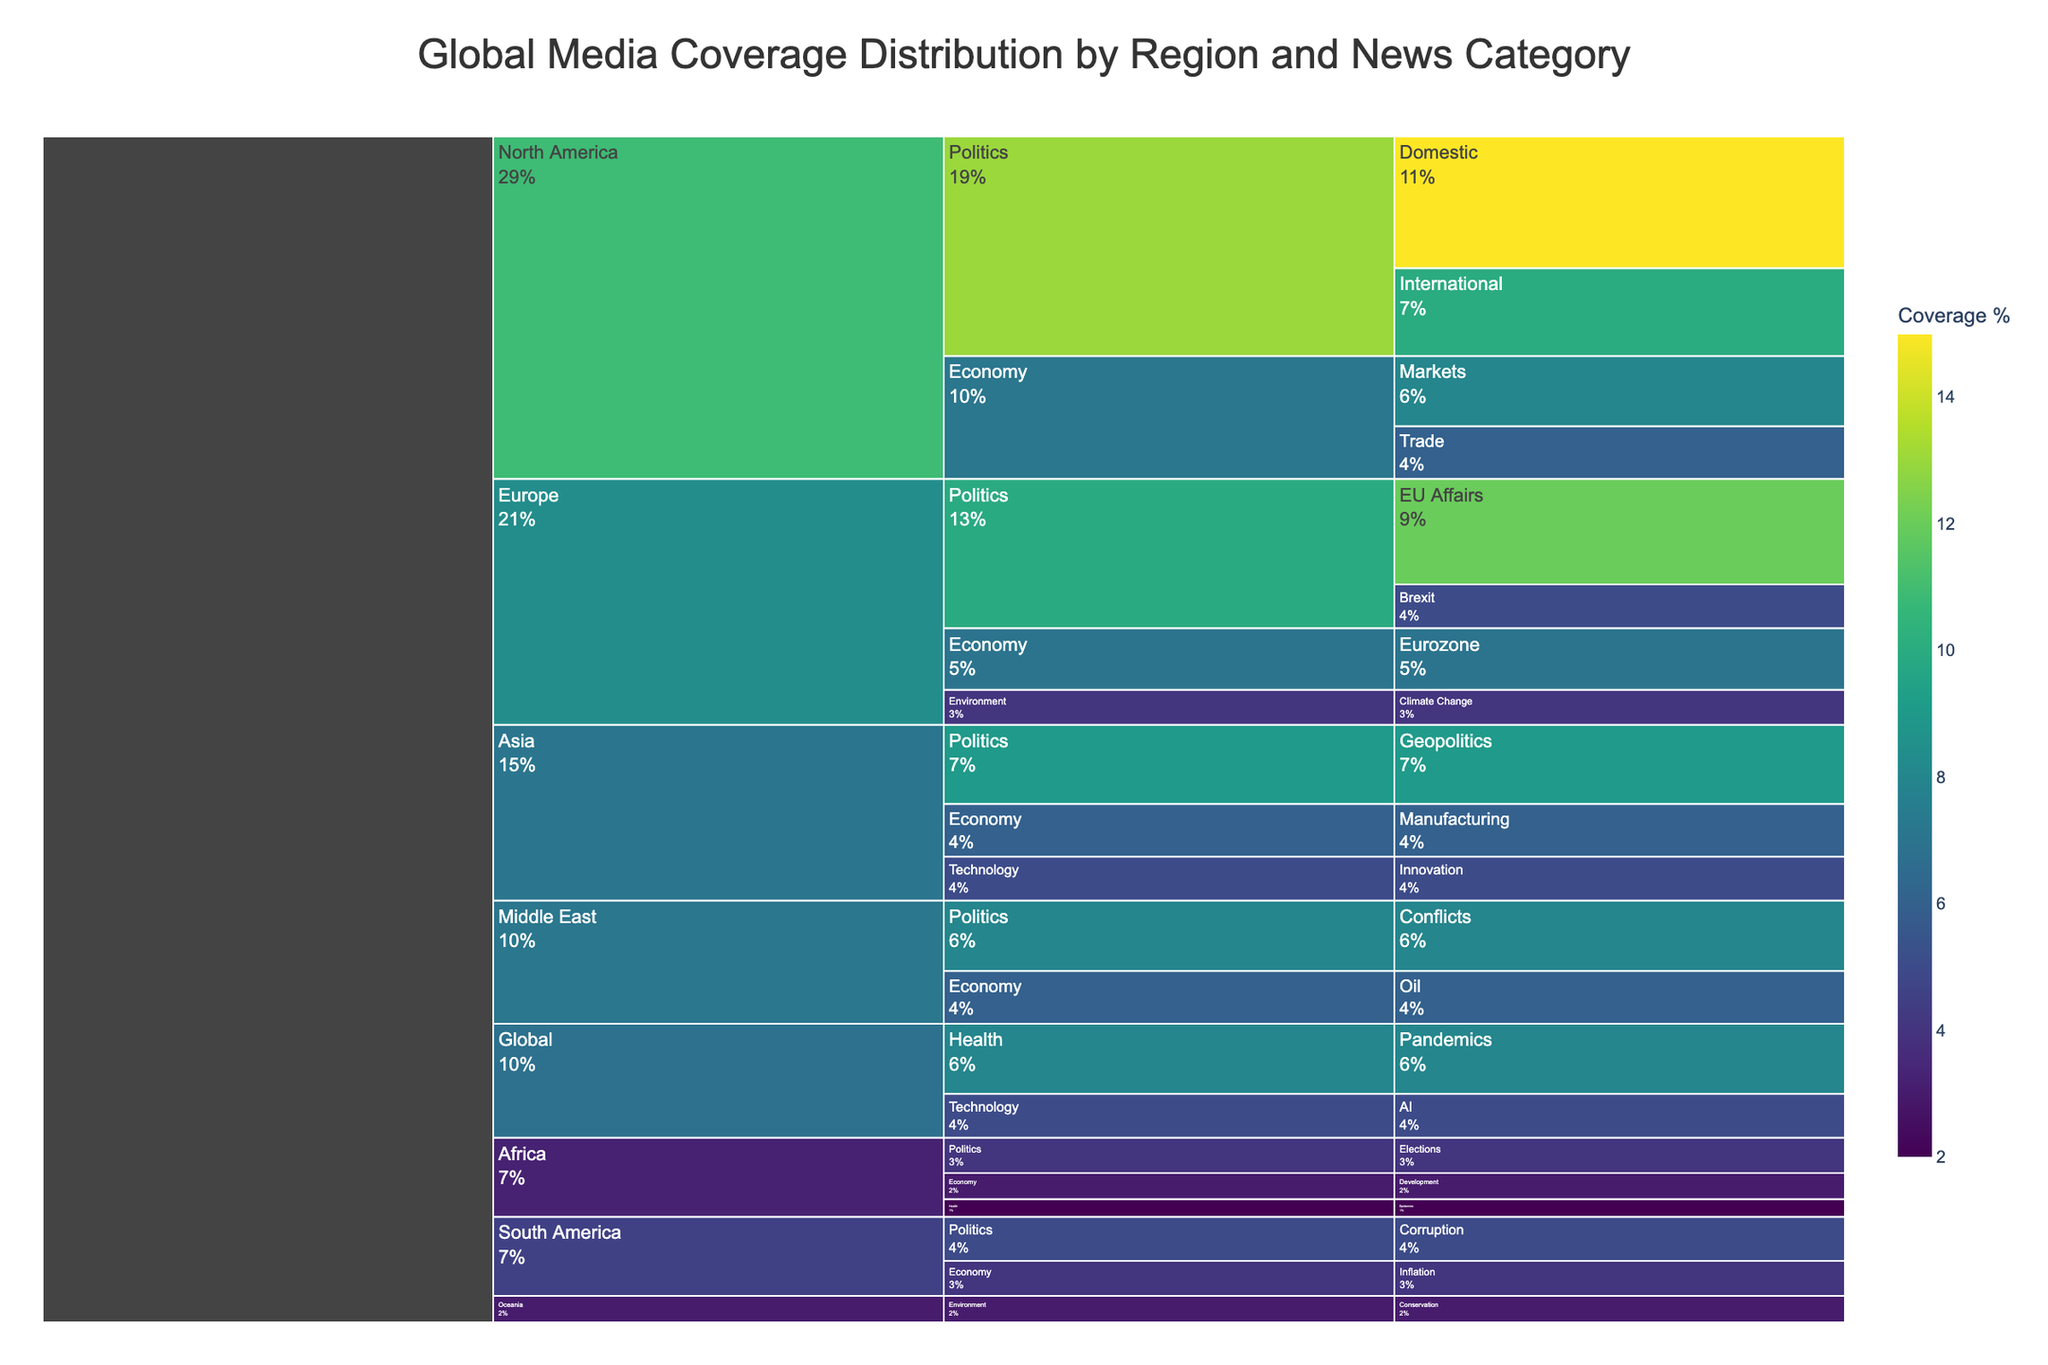What region has the highest media coverage for politics? The icicle chart shows that North America has the highest media coverage for politics, with Domestic and International categories adding up to 25%.
Answer: North America Which region has the least media coverage overall? By looking at the overall size of the regions, Oceania has the smallest representation with only the Environment category under Conservation at 3%.
Answer: Oceania How does the coverage for Technology in Asia compare to Global coverage for Technology? The chart indicates that Asia has a 5% coverage for Technology (specifically Innovation), and globally, there is also a 5% coverage for Technology focused on AI.
Answer: They are equal What is the total media coverage percentage for the Economy in Africa? Africa has two Economy subcategories: Development (3%) and adding these provides the total coverage. 3%
Answer: 3% Which region has more coverage: Middle East Politics or South America Politics? Middle East has Politics coverage for Conflicts at 8%, while South America has Politics coverage for Corruption at 5%, so the Middle East has more.
Answer: Middle East How does the coverage of Health in Africa compare to Health coverage globally? Africa's Health coverage for Epidemics is 2%, whereas the global Health coverage for Pandemics is much higher at 8%, making the global coverage higher.
Answer: Global is higher What is the total media coverage for Politics across all regions? Summing Politics coverage across all regions: North America (25%) + Europe (17%) + Asia (9%) + Middle East (8%) + Africa (4%) + South America (5%) = 68%.
Answer: 68% Which subgroup of Economy has the highest coverage and in which region? Different subcategories of the Economy are present. Markets in North America has 8%, which is the highest within the Economy category.
Answer: Markets in North America What is the combined media coverage percentage for Environment across all regions? Adding Environment coverage across regions: Europe (4%) + Oceania (3%) = 7%.
Answer: 7% Between North America and Europe, which region has a higher total coverage for Economy-related news? North America has Markets (8%) and Trade (6%) totaling 14%. Europe has Eurozone (7%), which totals to 7%. Thus, North America has higher coverage for Economy-related news.
Answer: North America 